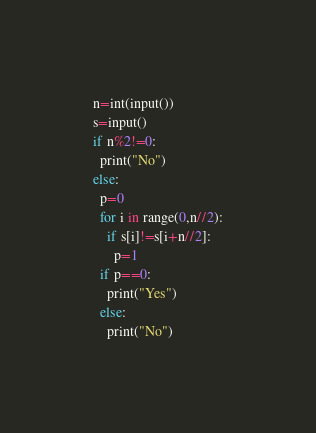<code> <loc_0><loc_0><loc_500><loc_500><_Python_>n=int(input())
s=input()
if n%2!=0:
  print("No")
else:
  p=0
  for i in range(0,n//2):
    if s[i]!=s[i+n//2]:
      p=1
  if p==0:
    print("Yes")
  else:
    print("No")</code> 